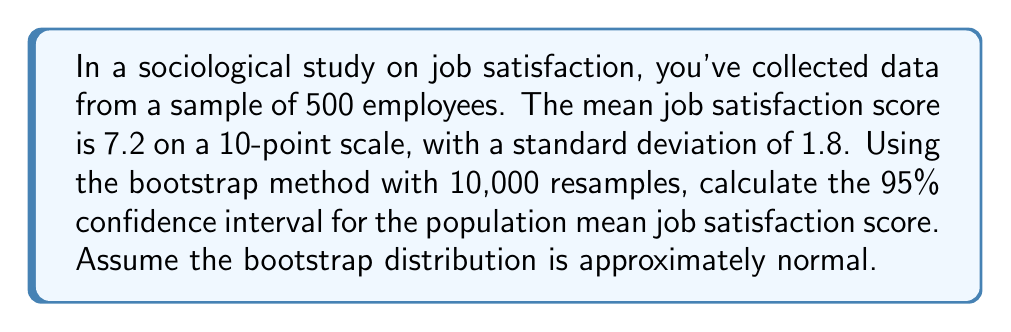Provide a solution to this math problem. To calculate the confidence interval using the bootstrap method, follow these steps:

1. Understand the given information:
   - Sample size: $n = 500$
   - Sample mean: $\bar{x} = 7.2$
   - Sample standard deviation: $s = 1.8$
   - Number of bootstrap resamples: $B = 10,000$
   - Confidence level: 95%

2. Calculate the standard error of the bootstrap distribution:
   The standard error is estimated by the standard deviation of the bootstrap distribution, which can be approximated using the formula:
   
   $$SE_{boot} = \frac{s}{\sqrt{n}} = \frac{1.8}{\sqrt{500}} \approx 0.0805$$

3. Determine the critical value for a 95% confidence interval:
   For a 95% CI, use the z-score of 1.96 (assuming normality of the bootstrap distribution).

4. Calculate the margin of error:
   $$ME = z_{0.975} \times SE_{boot} = 1.96 \times 0.0805 \approx 0.1578$$

5. Compute the confidence interval:
   $$CI = \bar{x} \pm ME = 7.2 \pm 0.1578$$

   Lower bound: $7.2 - 0.1578 = 7.0422$
   Upper bound: $7.2 + 0.1578 = 7.3578$

Therefore, the 95% confidence interval for the population mean job satisfaction score is approximately (7.0422, 7.3578).
Answer: (7.0422, 7.3578) 